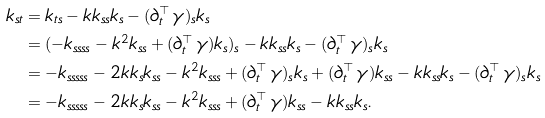Convert formula to latex. <formula><loc_0><loc_0><loc_500><loc_500>k _ { s t } & = k _ { t s } - k k _ { s s } k _ { s } - ( \partial _ { t } ^ { \top } \, \gamma ) _ { s } k _ { s } \\ & = ( - k _ { s s s s } - k ^ { 2 } k _ { s s } + ( \partial _ { t } ^ { \top } \, \gamma ) k _ { s } ) _ { s } - k k _ { s s } k _ { s } - ( \partial _ { t } ^ { \top } \, \gamma ) _ { s } k _ { s } \\ & = - k _ { s s s s s } - 2 k k _ { s } k _ { s s } - k ^ { 2 } k _ { s s s } + ( \partial _ { t } ^ { \top } \, \gamma ) _ { s } k _ { s } + ( \partial _ { t } ^ { \top } \, \gamma ) k _ { s s } - k k _ { s s } k _ { s } - ( \partial _ { t } ^ { \top } \, \gamma ) _ { s } k _ { s } \\ & = - k _ { s s s s s } - 2 k k _ { s } k _ { s s } - k ^ { 2 } k _ { s s s } + ( \partial _ { t } ^ { \top } \, \gamma ) k _ { s s } - k k _ { s s } k _ { s } .</formula> 